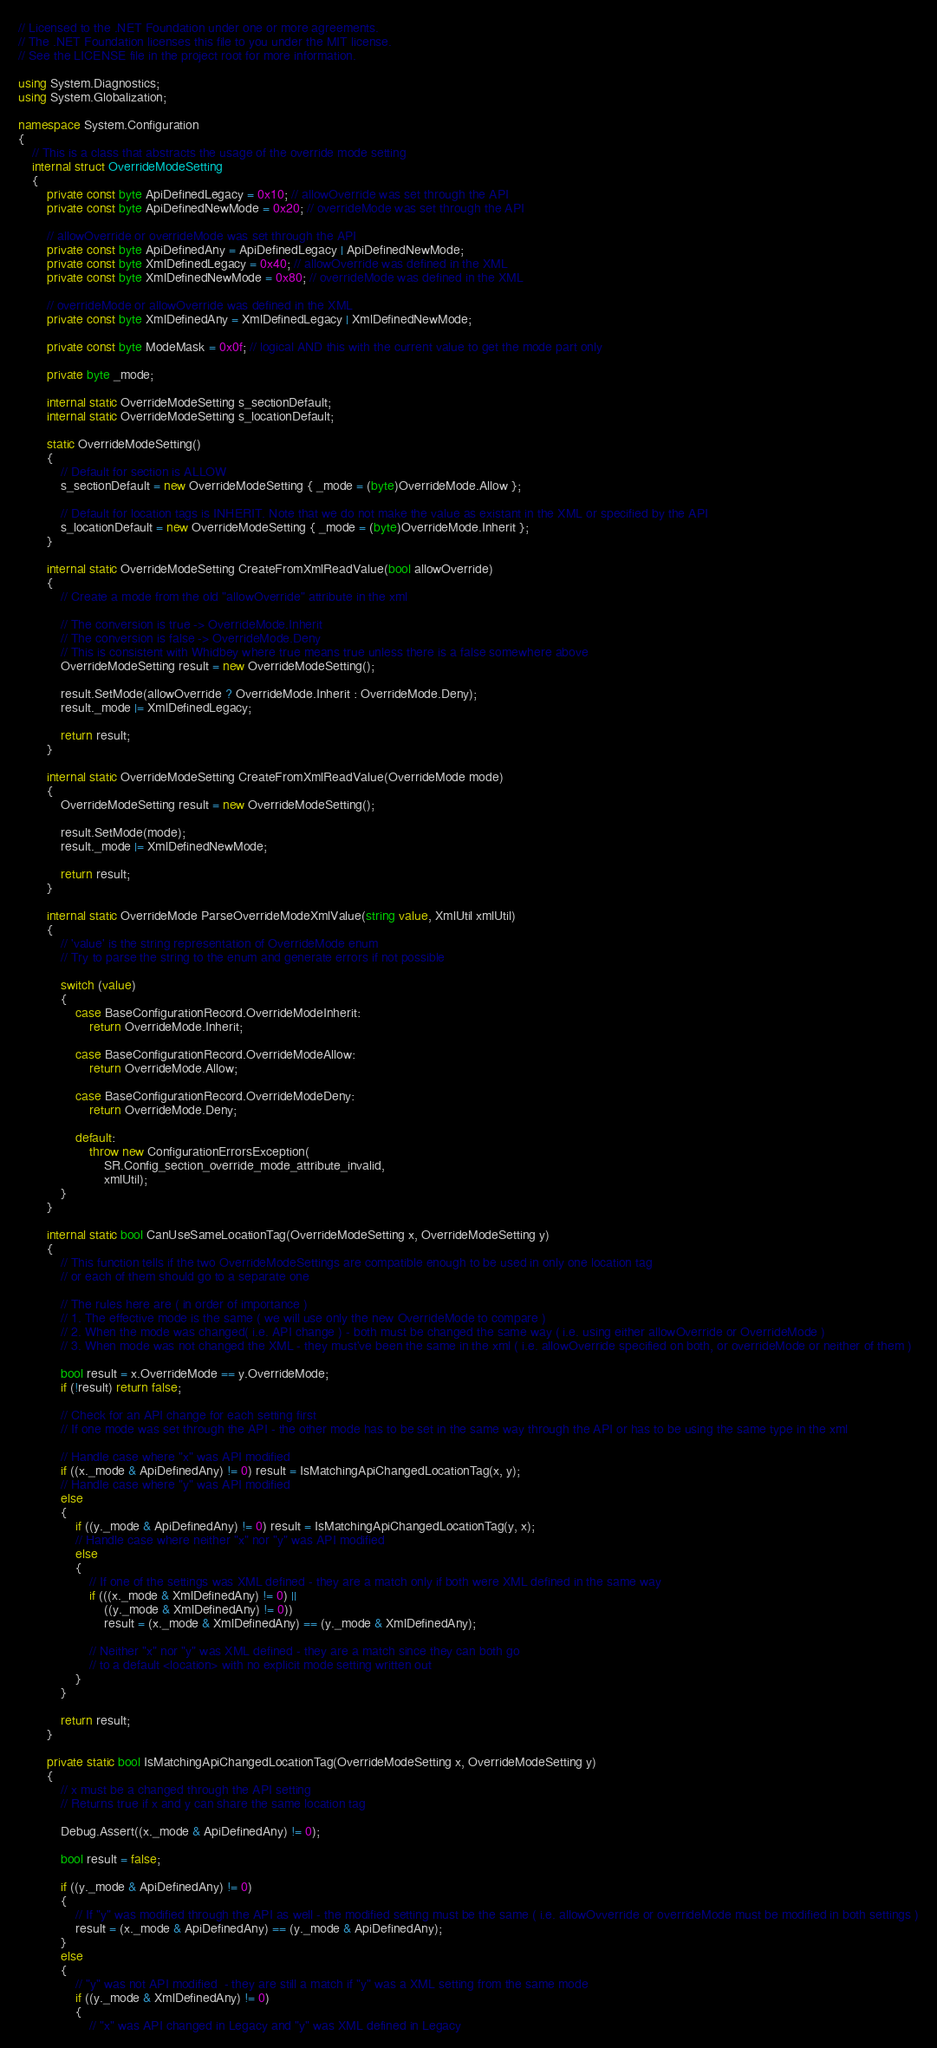Convert code to text. <code><loc_0><loc_0><loc_500><loc_500><_C#_>// Licensed to the .NET Foundation under one or more agreements.
// The .NET Foundation licenses this file to you under the MIT license.
// See the LICENSE file in the project root for more information.

using System.Diagnostics;
using System.Globalization;

namespace System.Configuration
{
    // This is a class that abstracts the usage of the override mode setting
    internal struct OverrideModeSetting
    {
        private const byte ApiDefinedLegacy = 0x10; // allowOverride was set through the API
        private const byte ApiDefinedNewMode = 0x20; // overrideMode was set through the API

        // allowOverride or overrideMode was set through the API
        private const byte ApiDefinedAny = ApiDefinedLegacy | ApiDefinedNewMode;
        private const byte XmlDefinedLegacy = 0x40; // allowOverride was defined in the XML
        private const byte XmlDefinedNewMode = 0x80; // overrideMode was defined in the XML

        // overrideMode or allowOverride was defined in the XML
        private const byte XmlDefinedAny = XmlDefinedLegacy | XmlDefinedNewMode;

        private const byte ModeMask = 0x0f; // logical AND this with the current value to get the mode part only

        private byte _mode;

        internal static OverrideModeSetting s_sectionDefault;
        internal static OverrideModeSetting s_locationDefault;

        static OverrideModeSetting()
        {
            // Default for section is ALLOW
            s_sectionDefault = new OverrideModeSetting { _mode = (byte)OverrideMode.Allow };

            // Default for location tags is INHERIT. Note that we do not make the value as existant in the XML or specified by the API
            s_locationDefault = new OverrideModeSetting { _mode = (byte)OverrideMode.Inherit };
        }

        internal static OverrideModeSetting CreateFromXmlReadValue(bool allowOverride)
        {
            // Create a mode from the old "allowOverride" attribute in the xml

            // The conversion is true -> OverrideMode.Inherit
            // The conversion is false -> OverrideMode.Deny
            // This is consistent with Whidbey where true means true unless there is a false somewhere above
            OverrideModeSetting result = new OverrideModeSetting();

            result.SetMode(allowOverride ? OverrideMode.Inherit : OverrideMode.Deny);
            result._mode |= XmlDefinedLegacy;

            return result;
        }

        internal static OverrideModeSetting CreateFromXmlReadValue(OverrideMode mode)
        {
            OverrideModeSetting result = new OverrideModeSetting();

            result.SetMode(mode);
            result._mode |= XmlDefinedNewMode;

            return result;
        }

        internal static OverrideMode ParseOverrideModeXmlValue(string value, XmlUtil xmlUtil)
        {
            // 'value' is the string representation of OverrideMode enum
            // Try to parse the string to the enum and generate errors if not possible

            switch (value)
            {
                case BaseConfigurationRecord.OverrideModeInherit:
                    return OverrideMode.Inherit;

                case BaseConfigurationRecord.OverrideModeAllow:
                    return OverrideMode.Allow;

                case BaseConfigurationRecord.OverrideModeDeny:
                    return OverrideMode.Deny;

                default:
                    throw new ConfigurationErrorsException(
                        SR.Config_section_override_mode_attribute_invalid,
                        xmlUtil);
            }
        }

        internal static bool CanUseSameLocationTag(OverrideModeSetting x, OverrideModeSetting y)
        {
            // This function tells if the two OverrideModeSettings are compatible enough to be used in only one location tag
            // or each of them should go to a separate one

            // The rules here are ( in order of importance )
            // 1. The effective mode is the same ( we will use only the new OverrideMode to compare )
            // 2. When the mode was changed( i.e. API change ) - both must be changed the same way ( i.e. using either allowOverride or OverrideMode )
            // 3. When mode was not changed the XML - they must've been the same in the xml ( i.e. allowOverride specified on both, or overrideMode or neither of them )

            bool result = x.OverrideMode == y.OverrideMode;
            if (!result) return false;

            // Check for an API change for each setting first
            // If one mode was set through the API - the other mode has to be set in the same way through the API or has to be using the same type in the xml

            // Handle case where "x" was API modified
            if ((x._mode & ApiDefinedAny) != 0) result = IsMatchingApiChangedLocationTag(x, y);
            // Handle case where "y" was API modified
            else
            {
                if ((y._mode & ApiDefinedAny) != 0) result = IsMatchingApiChangedLocationTag(y, x);
                // Handle case where neither "x" nor "y" was API modified
                else
                {
                    // If one of the settings was XML defined - they are a match only if both were XML defined in the same way
                    if (((x._mode & XmlDefinedAny) != 0) ||
                        ((y._mode & XmlDefinedAny) != 0))
                        result = (x._mode & XmlDefinedAny) == (y._mode & XmlDefinedAny);

                    // Neither "x" nor "y" was XML defined - they are a match since they can both go 
                    // to a default <location> with no explicit mode setting written out
                }
            }

            return result;
        }

        private static bool IsMatchingApiChangedLocationTag(OverrideModeSetting x, OverrideModeSetting y)
        {
            // x must be a changed through the API setting
            // Returns true if x and y can share the same location tag

            Debug.Assert((x._mode & ApiDefinedAny) != 0);

            bool result = false;

            if ((y._mode & ApiDefinedAny) != 0)
            {
                // If "y" was modified through the API as well - the modified setting must be the same ( i.e. allowOvverride or overrideMode must be modified in both settings )
                result = (x._mode & ApiDefinedAny) == (y._mode & ApiDefinedAny);
            }
            else
            {
                // "y" was not API modified  - they are still a match if "y" was a XML setting from the same mode
                if ((y._mode & XmlDefinedAny) != 0)
                {
                    // "x" was API changed in Legacy and "y" was XML defined in Legacy</code> 